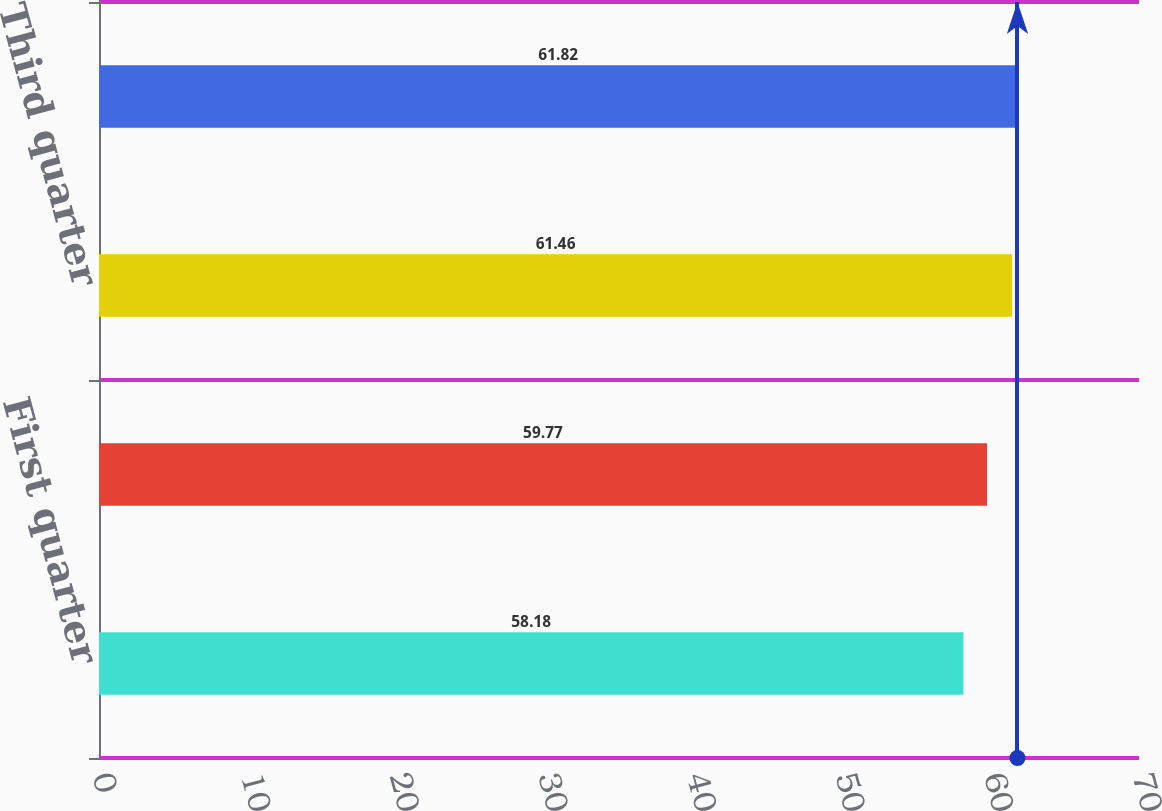Convert chart to OTSL. <chart><loc_0><loc_0><loc_500><loc_500><bar_chart><fcel>First quarter<fcel>Second quarter<fcel>Third quarter<fcel>Fourth quarter<nl><fcel>58.18<fcel>59.77<fcel>61.46<fcel>61.82<nl></chart> 